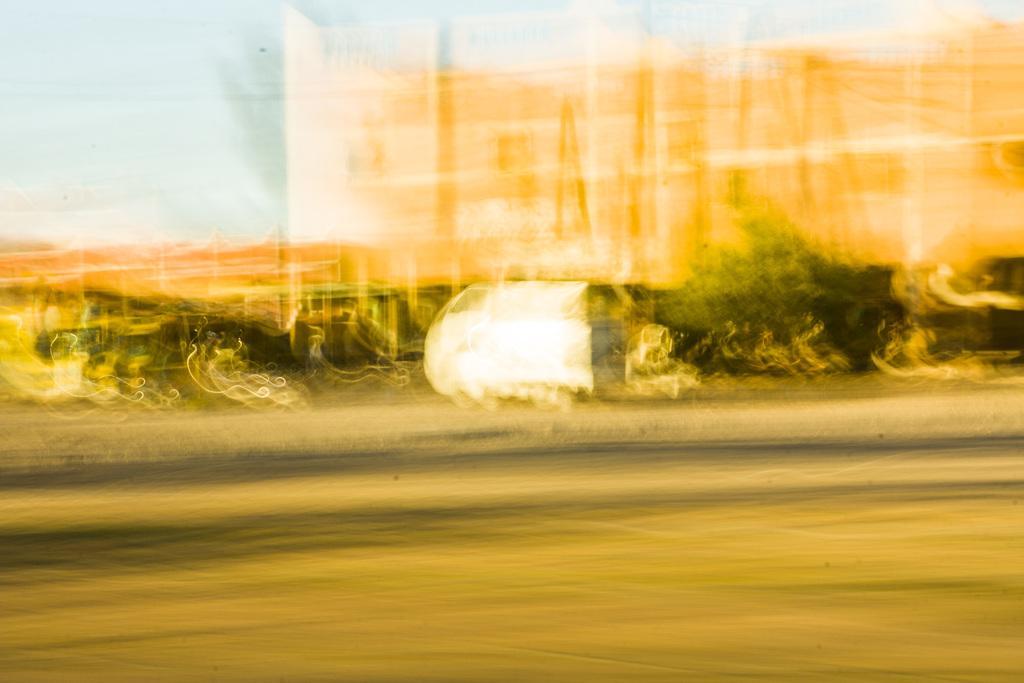How would you summarize this image in a sentence or two? This is the blurred image. I can see white,green,black and orange colors. 